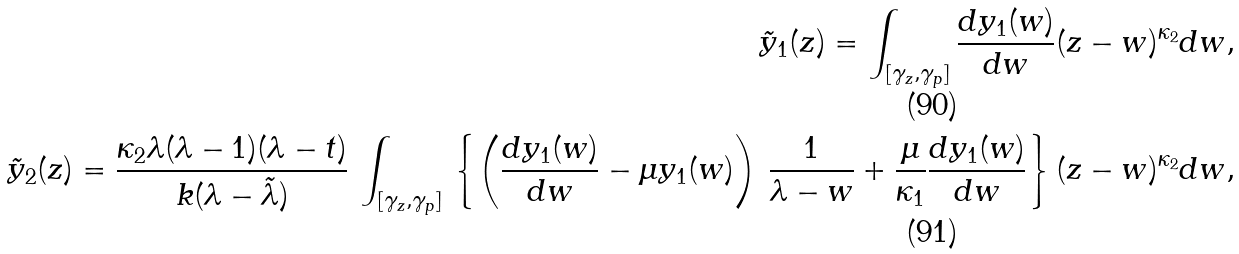<formula> <loc_0><loc_0><loc_500><loc_500>\tilde { y } _ { 1 } ( z ) = \int _ { [ \gamma _ { z } , \gamma _ { p } ] } \frac { d y _ { 1 } ( w ) } { d w } ( z - w ) ^ { \kappa _ { 2 } } d w , \\ \tilde { y } _ { 2 } ( z ) = \frac { \kappa _ { 2 } \lambda ( \lambda - 1 ) ( \lambda - t ) } { k ( \lambda - \tilde { \lambda } ) } \, \int _ { [ \gamma _ { z } , \gamma _ { p } ] } \, \left \{ \left ( \frac { d y _ { 1 } ( w ) } { d w } - \mu y _ { 1 } ( w ) \right ) \, \frac { 1 } { \lambda - w } + \frac { \mu } { \kappa _ { 1 } } \frac { d y _ { 1 } ( w ) } { d w } \right \} ( z - w ) ^ { \kappa _ { 2 } } d w ,</formula> 